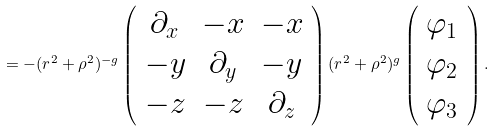<formula> <loc_0><loc_0><loc_500><loc_500>= - ( r ^ { 2 } + \rho ^ { 2 } ) ^ { - g } \left ( \begin{array} { c c c } \partial _ { x } & - x & - x \\ - y & \partial _ { y } & - y \\ - z & - z & \partial _ { z } \\ \end{array} \right ) ( r ^ { 2 } + \rho ^ { 2 } ) ^ { g } \left ( \begin{array} { c } \varphi _ { 1 } \\ \varphi _ { 2 } \\ \varphi _ { 3 } \\ \end{array} \right ) .</formula> 